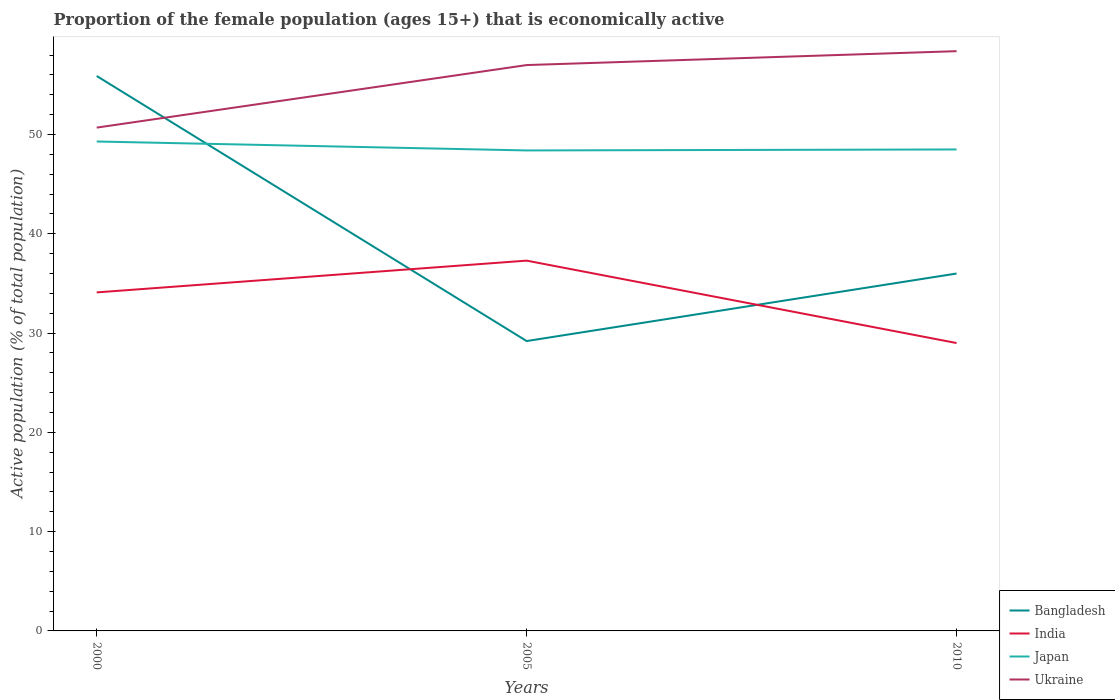Does the line corresponding to Bangladesh intersect with the line corresponding to Ukraine?
Your response must be concise. Yes. Is the number of lines equal to the number of legend labels?
Make the answer very short. Yes. Across all years, what is the maximum proportion of the female population that is economically active in Bangladesh?
Offer a very short reply. 29.2. In which year was the proportion of the female population that is economically active in Ukraine maximum?
Give a very brief answer. 2000. What is the total proportion of the female population that is economically active in Japan in the graph?
Give a very brief answer. 0.8. What is the difference between the highest and the second highest proportion of the female population that is economically active in Bangladesh?
Provide a succinct answer. 26.7. What is the difference between the highest and the lowest proportion of the female population that is economically active in Ukraine?
Provide a short and direct response. 2. How many lines are there?
Make the answer very short. 4. How many years are there in the graph?
Your response must be concise. 3. What is the difference between two consecutive major ticks on the Y-axis?
Your answer should be compact. 10. Are the values on the major ticks of Y-axis written in scientific E-notation?
Make the answer very short. No. Where does the legend appear in the graph?
Offer a very short reply. Bottom right. How many legend labels are there?
Give a very brief answer. 4. What is the title of the graph?
Give a very brief answer. Proportion of the female population (ages 15+) that is economically active. Does "Central African Republic" appear as one of the legend labels in the graph?
Keep it short and to the point. No. What is the label or title of the Y-axis?
Ensure brevity in your answer.  Active population (% of total population). What is the Active population (% of total population) of Bangladesh in 2000?
Ensure brevity in your answer.  55.9. What is the Active population (% of total population) of India in 2000?
Ensure brevity in your answer.  34.1. What is the Active population (% of total population) of Japan in 2000?
Ensure brevity in your answer.  49.3. What is the Active population (% of total population) of Ukraine in 2000?
Make the answer very short. 50.7. What is the Active population (% of total population) of Bangladesh in 2005?
Keep it short and to the point. 29.2. What is the Active population (% of total population) of India in 2005?
Give a very brief answer. 37.3. What is the Active population (% of total population) of Japan in 2005?
Your response must be concise. 48.4. What is the Active population (% of total population) of Bangladesh in 2010?
Make the answer very short. 36. What is the Active population (% of total population) of India in 2010?
Give a very brief answer. 29. What is the Active population (% of total population) in Japan in 2010?
Provide a succinct answer. 48.5. What is the Active population (% of total population) in Ukraine in 2010?
Give a very brief answer. 58.4. Across all years, what is the maximum Active population (% of total population) in Bangladesh?
Offer a terse response. 55.9. Across all years, what is the maximum Active population (% of total population) in India?
Offer a terse response. 37.3. Across all years, what is the maximum Active population (% of total population) of Japan?
Offer a terse response. 49.3. Across all years, what is the maximum Active population (% of total population) of Ukraine?
Give a very brief answer. 58.4. Across all years, what is the minimum Active population (% of total population) of Bangladesh?
Make the answer very short. 29.2. Across all years, what is the minimum Active population (% of total population) of India?
Offer a terse response. 29. Across all years, what is the minimum Active population (% of total population) of Japan?
Your answer should be compact. 48.4. Across all years, what is the minimum Active population (% of total population) in Ukraine?
Provide a succinct answer. 50.7. What is the total Active population (% of total population) of Bangladesh in the graph?
Give a very brief answer. 121.1. What is the total Active population (% of total population) of India in the graph?
Make the answer very short. 100.4. What is the total Active population (% of total population) of Japan in the graph?
Offer a terse response. 146.2. What is the total Active population (% of total population) in Ukraine in the graph?
Provide a succinct answer. 166.1. What is the difference between the Active population (% of total population) of Bangladesh in 2000 and that in 2005?
Your response must be concise. 26.7. What is the difference between the Active population (% of total population) of Ukraine in 2000 and that in 2005?
Provide a short and direct response. -6.3. What is the difference between the Active population (% of total population) in Bangladesh in 2000 and that in 2010?
Your answer should be very brief. 19.9. What is the difference between the Active population (% of total population) of Ukraine in 2000 and that in 2010?
Offer a very short reply. -7.7. What is the difference between the Active population (% of total population) of Japan in 2005 and that in 2010?
Keep it short and to the point. -0.1. What is the difference between the Active population (% of total population) in Bangladesh in 2000 and the Active population (% of total population) in Japan in 2005?
Give a very brief answer. 7.5. What is the difference between the Active population (% of total population) in India in 2000 and the Active population (% of total population) in Japan in 2005?
Provide a succinct answer. -14.3. What is the difference between the Active population (% of total population) in India in 2000 and the Active population (% of total population) in Ukraine in 2005?
Your answer should be compact. -22.9. What is the difference between the Active population (% of total population) of Bangladesh in 2000 and the Active population (% of total population) of India in 2010?
Keep it short and to the point. 26.9. What is the difference between the Active population (% of total population) in India in 2000 and the Active population (% of total population) in Japan in 2010?
Offer a terse response. -14.4. What is the difference between the Active population (% of total population) in India in 2000 and the Active population (% of total population) in Ukraine in 2010?
Keep it short and to the point. -24.3. What is the difference between the Active population (% of total population) in Bangladesh in 2005 and the Active population (% of total population) in Japan in 2010?
Keep it short and to the point. -19.3. What is the difference between the Active population (% of total population) in Bangladesh in 2005 and the Active population (% of total population) in Ukraine in 2010?
Offer a very short reply. -29.2. What is the difference between the Active population (% of total population) in India in 2005 and the Active population (% of total population) in Ukraine in 2010?
Your answer should be very brief. -21.1. What is the average Active population (% of total population) of Bangladesh per year?
Your answer should be very brief. 40.37. What is the average Active population (% of total population) in India per year?
Offer a terse response. 33.47. What is the average Active population (% of total population) of Japan per year?
Give a very brief answer. 48.73. What is the average Active population (% of total population) in Ukraine per year?
Provide a succinct answer. 55.37. In the year 2000, what is the difference between the Active population (% of total population) in Bangladesh and Active population (% of total population) in India?
Keep it short and to the point. 21.8. In the year 2000, what is the difference between the Active population (% of total population) in India and Active population (% of total population) in Japan?
Provide a short and direct response. -15.2. In the year 2000, what is the difference between the Active population (% of total population) in India and Active population (% of total population) in Ukraine?
Make the answer very short. -16.6. In the year 2000, what is the difference between the Active population (% of total population) in Japan and Active population (% of total population) in Ukraine?
Provide a short and direct response. -1.4. In the year 2005, what is the difference between the Active population (% of total population) in Bangladesh and Active population (% of total population) in Japan?
Provide a succinct answer. -19.2. In the year 2005, what is the difference between the Active population (% of total population) in Bangladesh and Active population (% of total population) in Ukraine?
Your answer should be very brief. -27.8. In the year 2005, what is the difference between the Active population (% of total population) of India and Active population (% of total population) of Ukraine?
Your answer should be very brief. -19.7. In the year 2010, what is the difference between the Active population (% of total population) of Bangladesh and Active population (% of total population) of Japan?
Your answer should be very brief. -12.5. In the year 2010, what is the difference between the Active population (% of total population) of Bangladesh and Active population (% of total population) of Ukraine?
Offer a very short reply. -22.4. In the year 2010, what is the difference between the Active population (% of total population) in India and Active population (% of total population) in Japan?
Offer a very short reply. -19.5. In the year 2010, what is the difference between the Active population (% of total population) of India and Active population (% of total population) of Ukraine?
Keep it short and to the point. -29.4. What is the ratio of the Active population (% of total population) in Bangladesh in 2000 to that in 2005?
Your answer should be very brief. 1.91. What is the ratio of the Active population (% of total population) of India in 2000 to that in 2005?
Your response must be concise. 0.91. What is the ratio of the Active population (% of total population) of Japan in 2000 to that in 2005?
Make the answer very short. 1.02. What is the ratio of the Active population (% of total population) in Ukraine in 2000 to that in 2005?
Offer a terse response. 0.89. What is the ratio of the Active population (% of total population) of Bangladesh in 2000 to that in 2010?
Offer a very short reply. 1.55. What is the ratio of the Active population (% of total population) in India in 2000 to that in 2010?
Give a very brief answer. 1.18. What is the ratio of the Active population (% of total population) in Japan in 2000 to that in 2010?
Ensure brevity in your answer.  1.02. What is the ratio of the Active population (% of total population) in Ukraine in 2000 to that in 2010?
Make the answer very short. 0.87. What is the ratio of the Active population (% of total population) of Bangladesh in 2005 to that in 2010?
Offer a very short reply. 0.81. What is the ratio of the Active population (% of total population) in India in 2005 to that in 2010?
Give a very brief answer. 1.29. What is the ratio of the Active population (% of total population) of Ukraine in 2005 to that in 2010?
Provide a succinct answer. 0.98. What is the difference between the highest and the second highest Active population (% of total population) of Bangladesh?
Give a very brief answer. 19.9. What is the difference between the highest and the second highest Active population (% of total population) of India?
Your answer should be very brief. 3.2. What is the difference between the highest and the second highest Active population (% of total population) of Japan?
Offer a very short reply. 0.8. What is the difference between the highest and the second highest Active population (% of total population) of Ukraine?
Your answer should be very brief. 1.4. What is the difference between the highest and the lowest Active population (% of total population) of Bangladesh?
Make the answer very short. 26.7. What is the difference between the highest and the lowest Active population (% of total population) in India?
Your response must be concise. 8.3. What is the difference between the highest and the lowest Active population (% of total population) in Japan?
Make the answer very short. 0.9. 